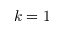Convert formula to latex. <formula><loc_0><loc_0><loc_500><loc_500>k = 1</formula> 